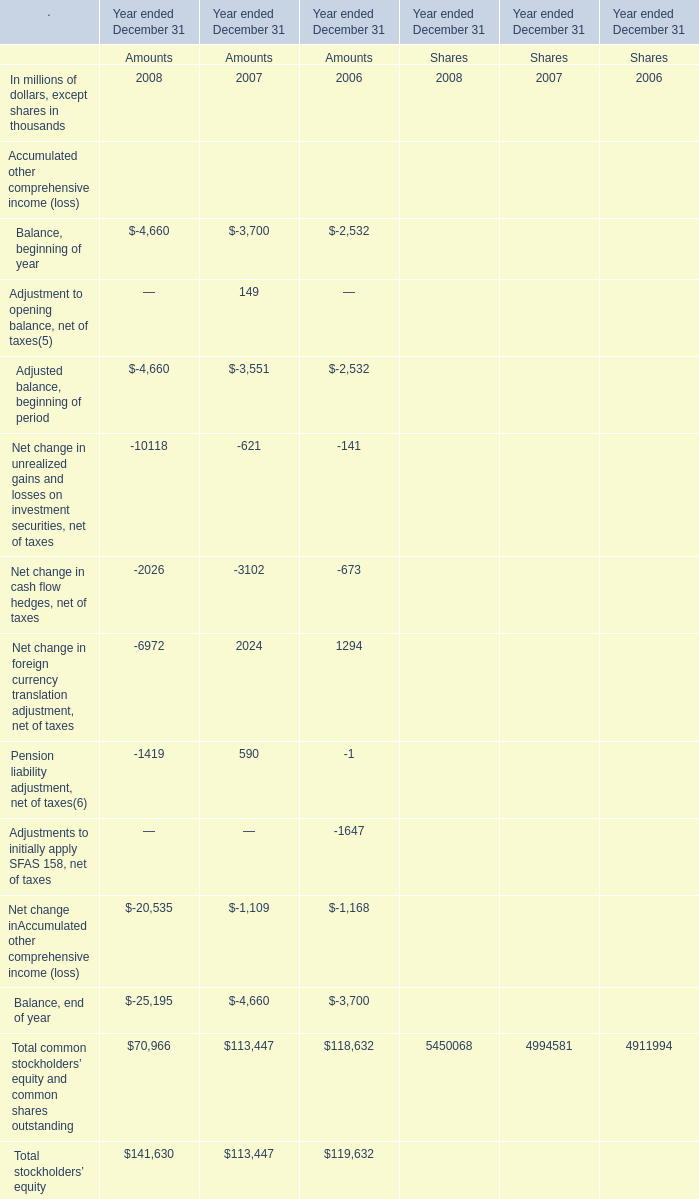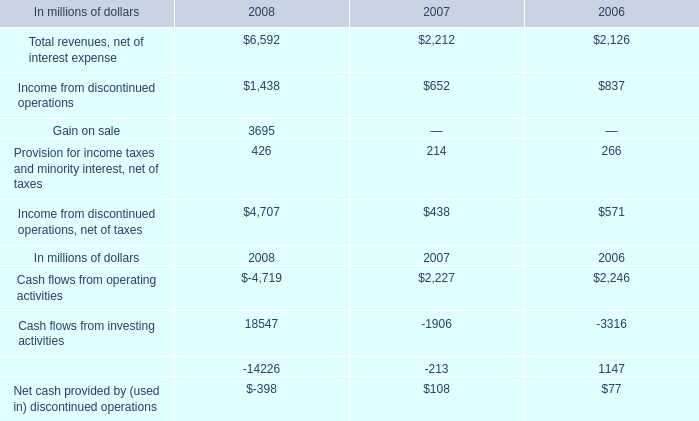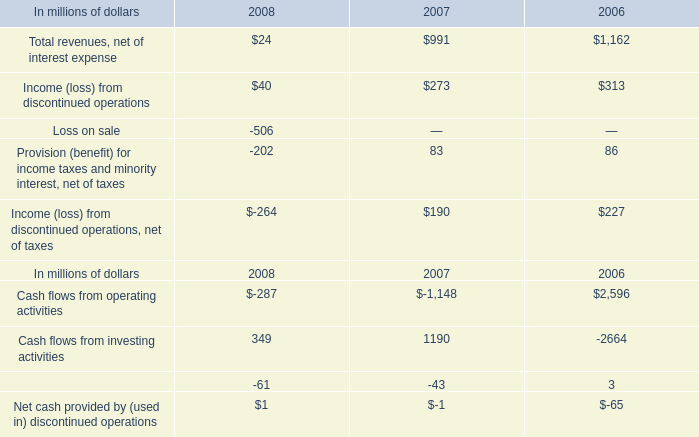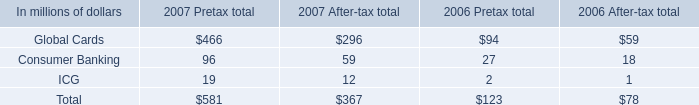What is the average amount of Income from discontinued operations of 2008, and Cash flows from investing activities of 2006 ? 
Computations: ((1438.0 + 2664.0) / 2)
Answer: 2051.0. 